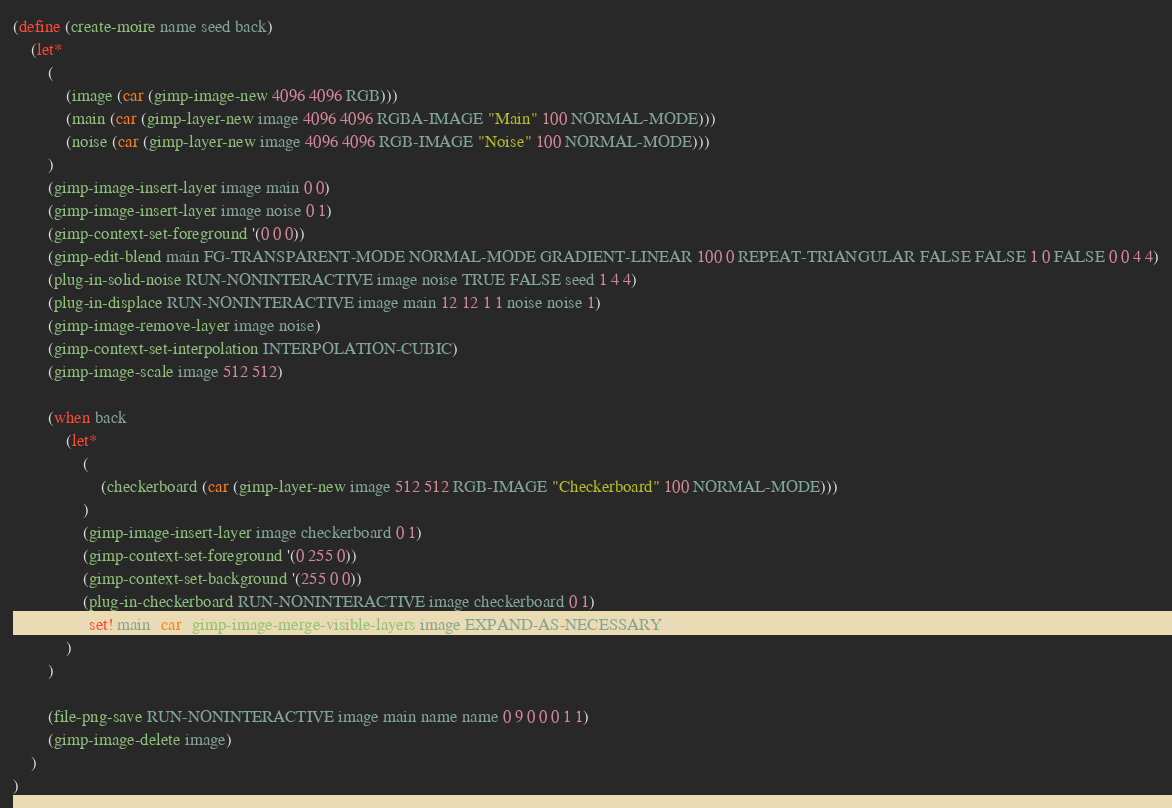<code> <loc_0><loc_0><loc_500><loc_500><_Scheme_>(define (create-moire name seed back)
	(let*
		(
			(image (car (gimp-image-new 4096 4096 RGB)))
			(main (car (gimp-layer-new image 4096 4096 RGBA-IMAGE "Main" 100 NORMAL-MODE)))
			(noise (car (gimp-layer-new image 4096 4096 RGB-IMAGE "Noise" 100 NORMAL-MODE)))
		)
		(gimp-image-insert-layer image main 0 0)
		(gimp-image-insert-layer image noise 0 1)
		(gimp-context-set-foreground '(0 0 0))
		(gimp-edit-blend main FG-TRANSPARENT-MODE NORMAL-MODE GRADIENT-LINEAR 100 0 REPEAT-TRIANGULAR FALSE FALSE 1 0 FALSE 0 0 4 4)
		(plug-in-solid-noise RUN-NONINTERACTIVE image noise TRUE FALSE seed 1 4 4)
		(plug-in-displace RUN-NONINTERACTIVE image main 12 12 1 1 noise noise 1)
		(gimp-image-remove-layer image noise)
		(gimp-context-set-interpolation INTERPOLATION-CUBIC)
		(gimp-image-scale image 512 512)

		(when back
			(let*
				(
					(checkerboard (car (gimp-layer-new image 512 512 RGB-IMAGE "Checkerboard" 100 NORMAL-MODE)))
				)
				(gimp-image-insert-layer image checkerboard 0 1)
				(gimp-context-set-foreground '(0 255 0))
				(gimp-context-set-background '(255 0 0))
				(plug-in-checkerboard RUN-NONINTERACTIVE image checkerboard 0 1)
				(set! main (car (gimp-image-merge-visible-layers image EXPAND-AS-NECESSARY)))
			)
		)

		(file-png-save RUN-NONINTERACTIVE image main name name 0 9 0 0 0 1 1)
		(gimp-image-delete image)
	)
)
</code> 